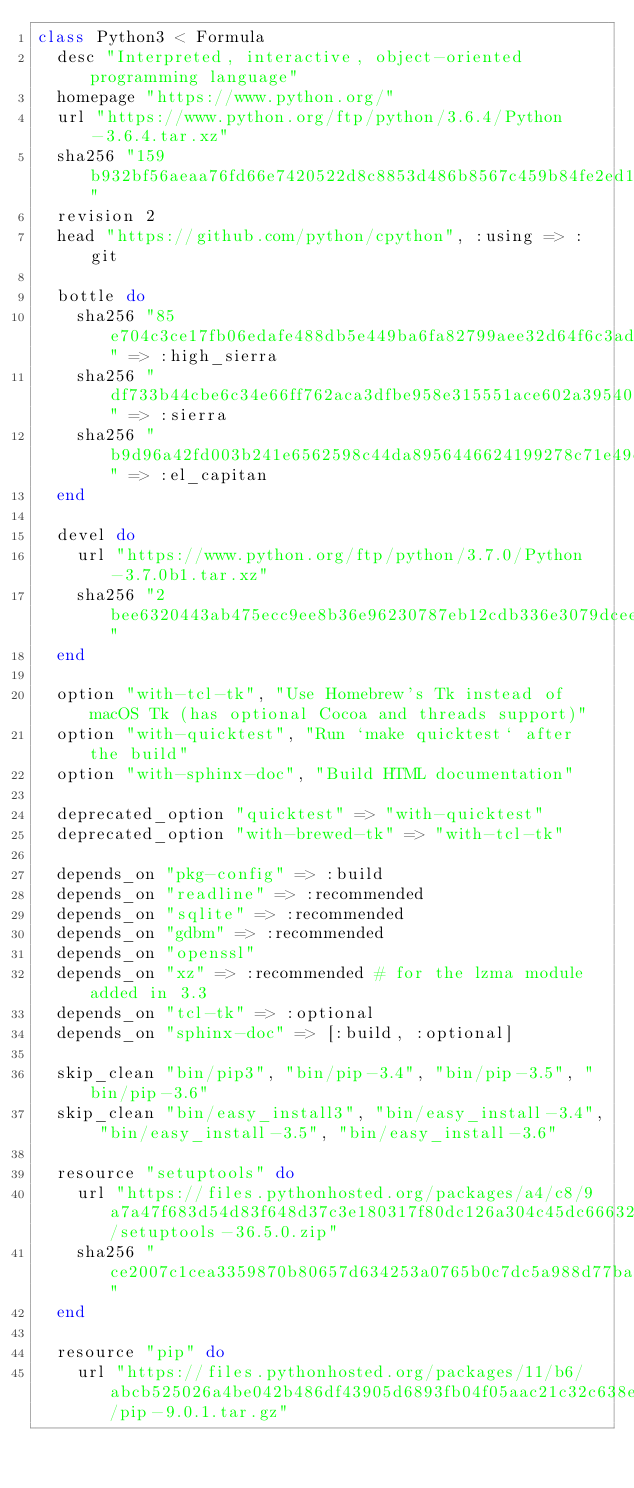Convert code to text. <code><loc_0><loc_0><loc_500><loc_500><_Ruby_>class Python3 < Formula
  desc "Interpreted, interactive, object-oriented programming language"
  homepage "https://www.python.org/"
  url "https://www.python.org/ftp/python/3.6.4/Python-3.6.4.tar.xz"
  sha256 "159b932bf56aeaa76fd66e7420522d8c8853d486b8567c459b84fe2ed13bcaba"
  revision 2
  head "https://github.com/python/cpython", :using => :git

  bottle do
    sha256 "85e704c3ce17fb06edafe488db5e449ba6fa82799aee32d64f6c3ad5414801e0" => :high_sierra
    sha256 "df733b44cbe6c34e66ff762aca3dfbe958e315551ace602a395400ed2b900616" => :sierra
    sha256 "b9d96a42fd003b241e6562598c44da8956446624199278c71e49c53df74fe4a4" => :el_capitan
  end

  devel do
    url "https://www.python.org/ftp/python/3.7.0/Python-3.7.0b1.tar.xz"
    sha256 "2bee6320443ab475ecc9ee8b36e96230787eb12cdb336e3079dceef23039b970"
  end

  option "with-tcl-tk", "Use Homebrew's Tk instead of macOS Tk (has optional Cocoa and threads support)"
  option "with-quicktest", "Run `make quicktest` after the build"
  option "with-sphinx-doc", "Build HTML documentation"

  deprecated_option "quicktest" => "with-quicktest"
  deprecated_option "with-brewed-tk" => "with-tcl-tk"

  depends_on "pkg-config" => :build
  depends_on "readline" => :recommended
  depends_on "sqlite" => :recommended
  depends_on "gdbm" => :recommended
  depends_on "openssl"
  depends_on "xz" => :recommended # for the lzma module added in 3.3
  depends_on "tcl-tk" => :optional
  depends_on "sphinx-doc" => [:build, :optional]

  skip_clean "bin/pip3", "bin/pip-3.4", "bin/pip-3.5", "bin/pip-3.6"
  skip_clean "bin/easy_install3", "bin/easy_install-3.4", "bin/easy_install-3.5", "bin/easy_install-3.6"

  resource "setuptools" do
    url "https://files.pythonhosted.org/packages/a4/c8/9a7a47f683d54d83f648d37c3e180317f80dc126a304c45dc6663246233a/setuptools-36.5.0.zip"
    sha256 "ce2007c1cea3359870b80657d634253a0765b0c7dc5a988d77ba803fc86f2c64"
  end

  resource "pip" do
    url "https://files.pythonhosted.org/packages/11/b6/abcb525026a4be042b486df43905d6893fb04f05aac21c32c638e939e447/pip-9.0.1.tar.gz"</code> 